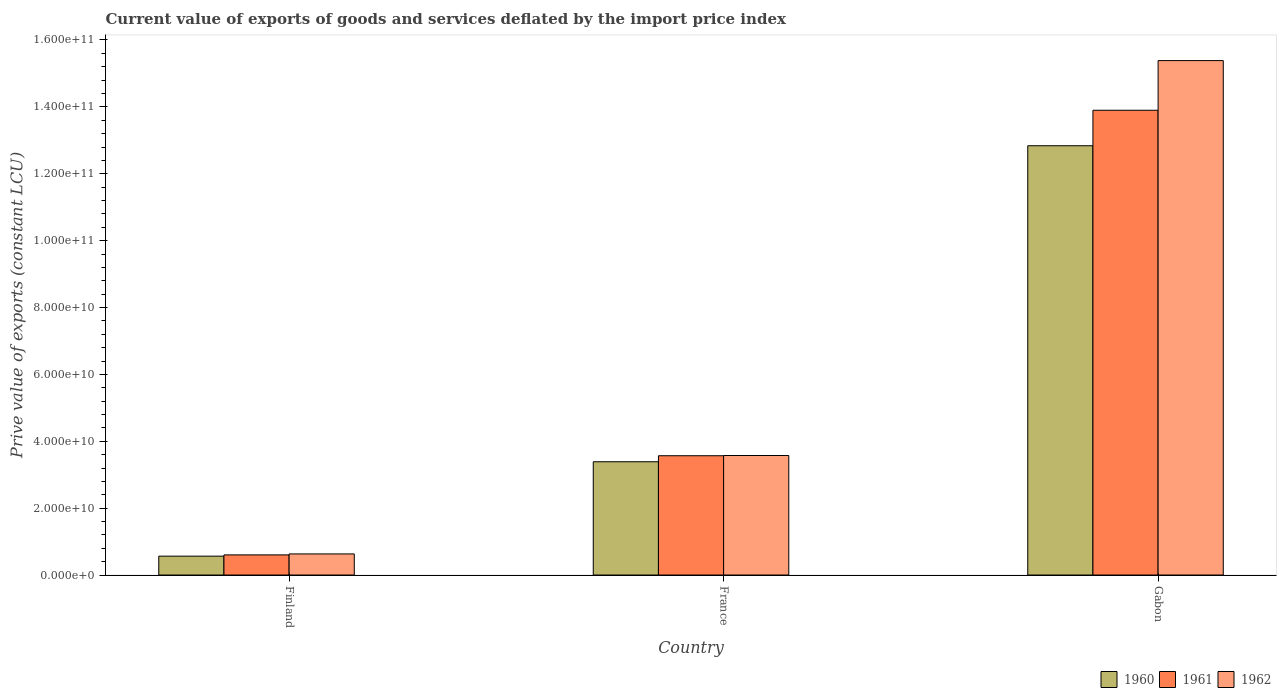How many groups of bars are there?
Ensure brevity in your answer.  3. Are the number of bars per tick equal to the number of legend labels?
Your response must be concise. Yes. Are the number of bars on each tick of the X-axis equal?
Your answer should be compact. Yes. How many bars are there on the 3rd tick from the right?
Offer a very short reply. 3. In how many cases, is the number of bars for a given country not equal to the number of legend labels?
Your response must be concise. 0. What is the prive value of exports in 1960 in France?
Your answer should be very brief. 3.39e+1. Across all countries, what is the maximum prive value of exports in 1960?
Your response must be concise. 1.28e+11. Across all countries, what is the minimum prive value of exports in 1960?
Give a very brief answer. 5.65e+09. In which country was the prive value of exports in 1960 maximum?
Make the answer very short. Gabon. What is the total prive value of exports in 1961 in the graph?
Make the answer very short. 1.81e+11. What is the difference between the prive value of exports in 1961 in Finland and that in Gabon?
Offer a very short reply. -1.33e+11. What is the difference between the prive value of exports in 1960 in France and the prive value of exports in 1961 in Gabon?
Your answer should be compact. -1.05e+11. What is the average prive value of exports in 1961 per country?
Your answer should be very brief. 6.02e+1. What is the difference between the prive value of exports of/in 1960 and prive value of exports of/in 1962 in Finland?
Your response must be concise. -6.62e+08. In how many countries, is the prive value of exports in 1960 greater than 148000000000 LCU?
Offer a very short reply. 0. What is the ratio of the prive value of exports in 1961 in France to that in Gabon?
Your answer should be very brief. 0.26. Is the difference between the prive value of exports in 1960 in Finland and France greater than the difference between the prive value of exports in 1962 in Finland and France?
Provide a succinct answer. Yes. What is the difference between the highest and the second highest prive value of exports in 1962?
Provide a short and direct response. 2.94e+1. What is the difference between the highest and the lowest prive value of exports in 1961?
Make the answer very short. 1.33e+11. In how many countries, is the prive value of exports in 1962 greater than the average prive value of exports in 1962 taken over all countries?
Offer a very short reply. 1. Is the sum of the prive value of exports in 1960 in Finland and France greater than the maximum prive value of exports in 1962 across all countries?
Make the answer very short. No. Are all the bars in the graph horizontal?
Your answer should be compact. No. Are the values on the major ticks of Y-axis written in scientific E-notation?
Offer a terse response. Yes. How many legend labels are there?
Provide a succinct answer. 3. What is the title of the graph?
Make the answer very short. Current value of exports of goods and services deflated by the import price index. What is the label or title of the X-axis?
Offer a terse response. Country. What is the label or title of the Y-axis?
Provide a succinct answer. Prive value of exports (constant LCU). What is the Prive value of exports (constant LCU) in 1960 in Finland?
Give a very brief answer. 5.65e+09. What is the Prive value of exports (constant LCU) in 1961 in Finland?
Provide a succinct answer. 6.02e+09. What is the Prive value of exports (constant LCU) of 1962 in Finland?
Provide a succinct answer. 6.31e+09. What is the Prive value of exports (constant LCU) in 1960 in France?
Your response must be concise. 3.39e+1. What is the Prive value of exports (constant LCU) in 1961 in France?
Your answer should be very brief. 3.57e+1. What is the Prive value of exports (constant LCU) of 1962 in France?
Make the answer very short. 3.57e+1. What is the Prive value of exports (constant LCU) of 1960 in Gabon?
Ensure brevity in your answer.  1.28e+11. What is the Prive value of exports (constant LCU) in 1961 in Gabon?
Ensure brevity in your answer.  1.39e+11. What is the Prive value of exports (constant LCU) in 1962 in Gabon?
Provide a short and direct response. 1.54e+11. Across all countries, what is the maximum Prive value of exports (constant LCU) of 1960?
Keep it short and to the point. 1.28e+11. Across all countries, what is the maximum Prive value of exports (constant LCU) of 1961?
Your response must be concise. 1.39e+11. Across all countries, what is the maximum Prive value of exports (constant LCU) in 1962?
Keep it short and to the point. 1.54e+11. Across all countries, what is the minimum Prive value of exports (constant LCU) in 1960?
Provide a short and direct response. 5.65e+09. Across all countries, what is the minimum Prive value of exports (constant LCU) in 1961?
Provide a short and direct response. 6.02e+09. Across all countries, what is the minimum Prive value of exports (constant LCU) in 1962?
Offer a very short reply. 6.31e+09. What is the total Prive value of exports (constant LCU) of 1960 in the graph?
Offer a very short reply. 1.68e+11. What is the total Prive value of exports (constant LCU) in 1961 in the graph?
Your answer should be very brief. 1.81e+11. What is the total Prive value of exports (constant LCU) of 1962 in the graph?
Provide a succinct answer. 1.96e+11. What is the difference between the Prive value of exports (constant LCU) in 1960 in Finland and that in France?
Offer a terse response. -2.82e+1. What is the difference between the Prive value of exports (constant LCU) of 1961 in Finland and that in France?
Provide a succinct answer. -2.97e+1. What is the difference between the Prive value of exports (constant LCU) of 1962 in Finland and that in France?
Ensure brevity in your answer.  -2.94e+1. What is the difference between the Prive value of exports (constant LCU) of 1960 in Finland and that in Gabon?
Make the answer very short. -1.23e+11. What is the difference between the Prive value of exports (constant LCU) of 1961 in Finland and that in Gabon?
Ensure brevity in your answer.  -1.33e+11. What is the difference between the Prive value of exports (constant LCU) of 1962 in Finland and that in Gabon?
Keep it short and to the point. -1.48e+11. What is the difference between the Prive value of exports (constant LCU) of 1960 in France and that in Gabon?
Offer a terse response. -9.45e+1. What is the difference between the Prive value of exports (constant LCU) in 1961 in France and that in Gabon?
Ensure brevity in your answer.  -1.03e+11. What is the difference between the Prive value of exports (constant LCU) of 1962 in France and that in Gabon?
Give a very brief answer. -1.18e+11. What is the difference between the Prive value of exports (constant LCU) of 1960 in Finland and the Prive value of exports (constant LCU) of 1961 in France?
Make the answer very short. -3.00e+1. What is the difference between the Prive value of exports (constant LCU) in 1960 in Finland and the Prive value of exports (constant LCU) in 1962 in France?
Offer a very short reply. -3.01e+1. What is the difference between the Prive value of exports (constant LCU) of 1961 in Finland and the Prive value of exports (constant LCU) of 1962 in France?
Provide a short and direct response. -2.97e+1. What is the difference between the Prive value of exports (constant LCU) in 1960 in Finland and the Prive value of exports (constant LCU) in 1961 in Gabon?
Offer a terse response. -1.33e+11. What is the difference between the Prive value of exports (constant LCU) in 1960 in Finland and the Prive value of exports (constant LCU) in 1962 in Gabon?
Keep it short and to the point. -1.48e+11. What is the difference between the Prive value of exports (constant LCU) in 1961 in Finland and the Prive value of exports (constant LCU) in 1962 in Gabon?
Provide a succinct answer. -1.48e+11. What is the difference between the Prive value of exports (constant LCU) in 1960 in France and the Prive value of exports (constant LCU) in 1961 in Gabon?
Offer a very short reply. -1.05e+11. What is the difference between the Prive value of exports (constant LCU) of 1960 in France and the Prive value of exports (constant LCU) of 1962 in Gabon?
Provide a succinct answer. -1.20e+11. What is the difference between the Prive value of exports (constant LCU) of 1961 in France and the Prive value of exports (constant LCU) of 1962 in Gabon?
Offer a terse response. -1.18e+11. What is the average Prive value of exports (constant LCU) in 1960 per country?
Keep it short and to the point. 5.60e+1. What is the average Prive value of exports (constant LCU) of 1961 per country?
Give a very brief answer. 6.02e+1. What is the average Prive value of exports (constant LCU) in 1962 per country?
Your answer should be very brief. 6.53e+1. What is the difference between the Prive value of exports (constant LCU) of 1960 and Prive value of exports (constant LCU) of 1961 in Finland?
Keep it short and to the point. -3.69e+08. What is the difference between the Prive value of exports (constant LCU) of 1960 and Prive value of exports (constant LCU) of 1962 in Finland?
Give a very brief answer. -6.62e+08. What is the difference between the Prive value of exports (constant LCU) of 1961 and Prive value of exports (constant LCU) of 1962 in Finland?
Provide a short and direct response. -2.93e+08. What is the difference between the Prive value of exports (constant LCU) in 1960 and Prive value of exports (constant LCU) in 1961 in France?
Offer a very short reply. -1.80e+09. What is the difference between the Prive value of exports (constant LCU) of 1960 and Prive value of exports (constant LCU) of 1962 in France?
Your response must be concise. -1.87e+09. What is the difference between the Prive value of exports (constant LCU) in 1961 and Prive value of exports (constant LCU) in 1962 in France?
Offer a very short reply. -6.74e+07. What is the difference between the Prive value of exports (constant LCU) in 1960 and Prive value of exports (constant LCU) in 1961 in Gabon?
Your answer should be compact. -1.06e+1. What is the difference between the Prive value of exports (constant LCU) of 1960 and Prive value of exports (constant LCU) of 1962 in Gabon?
Give a very brief answer. -2.55e+1. What is the difference between the Prive value of exports (constant LCU) in 1961 and Prive value of exports (constant LCU) in 1962 in Gabon?
Keep it short and to the point. -1.49e+1. What is the ratio of the Prive value of exports (constant LCU) in 1961 in Finland to that in France?
Offer a very short reply. 0.17. What is the ratio of the Prive value of exports (constant LCU) in 1962 in Finland to that in France?
Your answer should be compact. 0.18. What is the ratio of the Prive value of exports (constant LCU) of 1960 in Finland to that in Gabon?
Offer a terse response. 0.04. What is the ratio of the Prive value of exports (constant LCU) in 1961 in Finland to that in Gabon?
Provide a succinct answer. 0.04. What is the ratio of the Prive value of exports (constant LCU) of 1962 in Finland to that in Gabon?
Ensure brevity in your answer.  0.04. What is the ratio of the Prive value of exports (constant LCU) of 1960 in France to that in Gabon?
Your response must be concise. 0.26. What is the ratio of the Prive value of exports (constant LCU) of 1961 in France to that in Gabon?
Your answer should be compact. 0.26. What is the ratio of the Prive value of exports (constant LCU) of 1962 in France to that in Gabon?
Provide a short and direct response. 0.23. What is the difference between the highest and the second highest Prive value of exports (constant LCU) in 1960?
Ensure brevity in your answer.  9.45e+1. What is the difference between the highest and the second highest Prive value of exports (constant LCU) of 1961?
Your answer should be compact. 1.03e+11. What is the difference between the highest and the second highest Prive value of exports (constant LCU) of 1962?
Make the answer very short. 1.18e+11. What is the difference between the highest and the lowest Prive value of exports (constant LCU) of 1960?
Ensure brevity in your answer.  1.23e+11. What is the difference between the highest and the lowest Prive value of exports (constant LCU) in 1961?
Your answer should be very brief. 1.33e+11. What is the difference between the highest and the lowest Prive value of exports (constant LCU) in 1962?
Keep it short and to the point. 1.48e+11. 